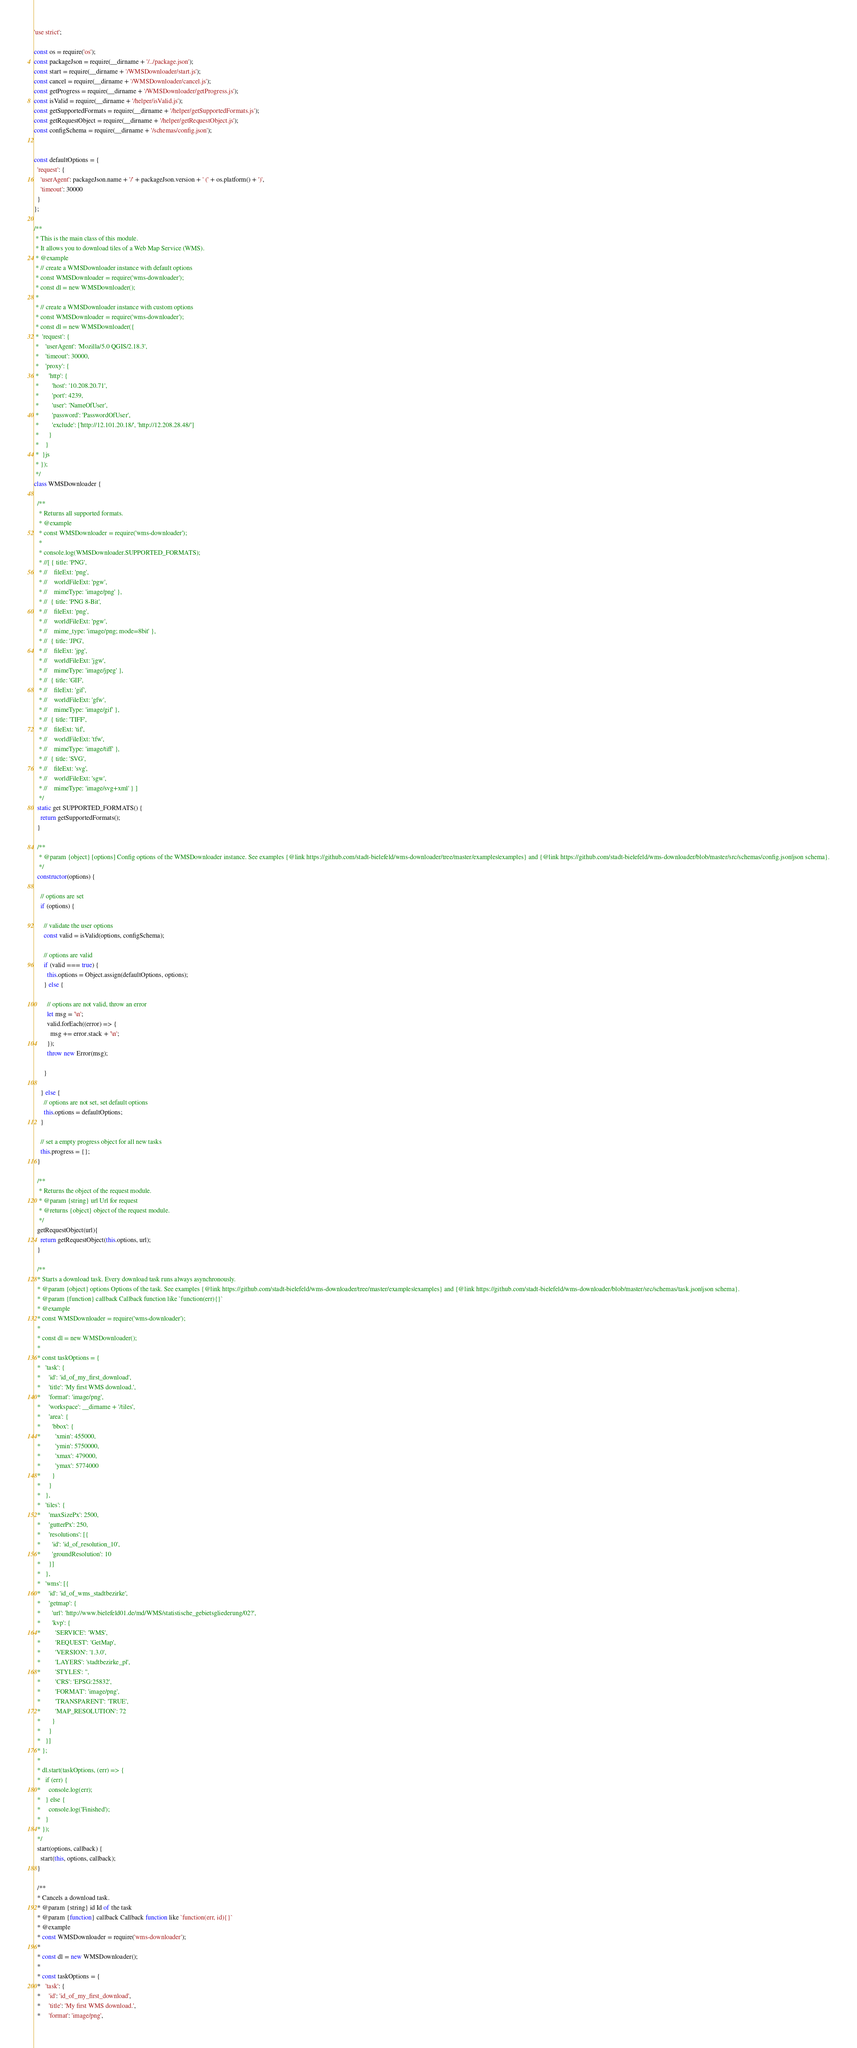Convert code to text. <code><loc_0><loc_0><loc_500><loc_500><_JavaScript_>'use strict';

const os = require('os');
const packageJson = require(__dirname + '/../package.json');
const start = require(__dirname + '/WMSDownloader/start.js');
const cancel = require(__dirname + '/WMSDownloader/cancel.js');
const getProgress = require(__dirname + '/WMSDownloader/getProgress.js');
const isValid = require(__dirname + '/helper/isValid.js');
const getSupportedFormats = require(__dirname + '/helper/getSupportedFormats.js');
const getRequestObject = require(__dirname + '/helper/getRequestObject.js');
const configSchema = require(__dirname + '/schemas/config.json');


const defaultOptions = {
  'request': {
    'userAgent': packageJson.name + '/' + packageJson.version + ' (' + os.platform() + ')',
    'timeout': 30000
  }
};

/**
 * This is the main class of this module.
 * It allows you to download tiles of a Web Map Service (WMS).
 * @example
 * // create a WMSDownloader instance with default options
 * const WMSDownloader = require('wms-downloader');
 * const dl = new WMSDownloader();
 * 
 * // create a WMSDownloader instance with custom options
 * const WMSDownloader = require('wms-downloader');
 * const dl = new WMSDownloader({
 *  'request': {
 *    'userAgent': 'Mozilla/5.0 QGIS/2.18.3',
 *    'timeout': 30000,
 *    'proxy': {
 *      'http': {
 *        'host': '10.208.20.71',
 *        'port': 4239,
 *        'user': 'NameOfUser',
 *        'password': 'PasswordOfUser',
 *        'exclude': ['http://12.101.20.18/', 'http://12.208.28.48/']
 *      }
 *    }
 *  }js
 * });
 */
class WMSDownloader {

  /**
   * Returns all supported formats.
   * @example
   * const WMSDownloader = require('wms-downloader');
   * 
   * console.log(WMSDownloader.SUPPORTED_FORMATS);
   * //[ { title: 'PNG',
   * //    fileExt: 'png',
   * //    worldFileExt: 'pgw',
   * //    mimeType: 'image/png' },
   * //  { title: 'PNG 8-Bit',
   * //    fileExt: 'png',
   * //    worldFileExt: 'pgw',
   * //    mime_type: 'image/png; mode=8bit' },
   * //  { title: 'JPG',
   * //    fileExt: 'jpg',
   * //    worldFileExt: 'jgw',
   * //    mimeType: 'image/jpeg' },
   * //  { title: 'GIF',
   * //    fileExt: 'gif',
   * //    worldFileExt: 'gfw',
   * //    mimeType: 'image/gif' },
   * //  { title: 'TIFF',
   * //    fileExt: 'tif',
   * //    worldFileExt: 'tfw',
   * //    mimeType: 'image/tiff' },
   * //  { title: 'SVG',
   * //    fileExt: 'svg',
   * //    worldFileExt: 'sgw',
   * //    mimeType: 'image/svg+xml' } ]
   */
  static get SUPPORTED_FORMATS() {
    return getSupportedFormats();
  }

  /**
   * @param {object} [options] Config options of the WMSDownloader instance. See examples {@link https://github.com/stadt-bielefeld/wms-downloader/tree/master/examples|examples} and {@link https://github.com/stadt-bielefeld/wms-downloader/blob/master/src/schemas/config.json|json schema}.
   */
  constructor(options) {

    // options are set
    if (options) {

      // validate the user options
      const valid = isValid(options, configSchema);

      // options are valid
      if (valid === true) {
        this.options = Object.assign(defaultOptions, options);
      } else {

        // options are not valid, throw an error
        let msg = '\n';
        valid.forEach((error) => {
          msg += error.stack + '\n';
        });
        throw new Error(msg);

      }

    } else {
      // options are not set, set default options
      this.options = defaultOptions;
    }

    // set a empty progress object for all new tasks
    this.progress = {};
  }

  /**
   * Returns the object of the request module.
   * @param {string} url Url for request
   * @returns {object} object of the request module.
   */
  getRequestObject(url){
    return getRequestObject(this.options, url);
  }

  /**
  * Starts a download task. Every download task runs always asynchronously.
  * @param {object} options Options of the task. See examples {@link https://github.com/stadt-bielefeld/wms-downloader/tree/master/examples|examples} and {@link https://github.com/stadt-bielefeld/wms-downloader/blob/master/src/schemas/task.json|json schema}.
  * @param {function} callback Callback function like `function(err){}`
  * @example
  * const WMSDownloader = require('wms-downloader');
  * 
  * const dl = new WMSDownloader();
  * 
  * const taskOptions = {
  *   'task': {
  *     'id': 'id_of_my_first_download',
  *     'title': 'My first WMS download.',
  *     'format': 'image/png',
  *     'workspace': __dirname + '/tiles',
  *     'area': {
  *       'bbox': {
  *         'xmin': 455000,
  *         'ymin': 5750000,
  *         'xmax': 479000,
  *         'ymax': 5774000
  *       }
  *     }
  *   },
  *   'tiles': {
  *     'maxSizePx': 2500,
  *     'gutterPx': 250,
  *     'resolutions': [{
  *       'id': 'id_of_resolution_10',
  *       'groundResolution': 10
  *     }]
  *   },
  *   'wms': [{
  *     'id': 'id_of_wms_stadtbezirke',
  *     'getmap': {
  *       'url': 'http://www.bielefeld01.de/md/WMS/statistische_gebietsgliederung/02?',
  *       'kvp': {
  *         'SERVICE': 'WMS',
  *         'REQUEST': 'GetMap',
  *         'VERSION': '1.3.0',
  *         'LAYERS': 'stadtbezirke_pl',
  *         'STYLES': '',
  *         'CRS': 'EPSG:25832',
  *         'FORMAT': 'image/png',
  *         'TRANSPARENT': 'TRUE',
  *         'MAP_RESOLUTION': 72
  *       }
  *     }
  *   }]
  * };
  *
  * dl.start(taskOptions, (err) => {
  *   if (err) {
  *     console.log(err);
  *   } else {
  *     console.log('Finished');
  *   }
  * });
  */
  start(options, callback) {
    start(this, options, callback);
  }

  /**
  * Cancels a download task.
  * @param {string} id Id of the task
  * @param {function} callback Callback function like `function(err, id){}`
  * @example
  * const WMSDownloader = require('wms-downloader');
  * 
  * const dl = new WMSDownloader();
  * 
  * const taskOptions = {
  *   'task': {
  *     'id': 'id_of_my_first_download',
  *     'title': 'My first WMS download.',
  *     'format': 'image/png',</code> 